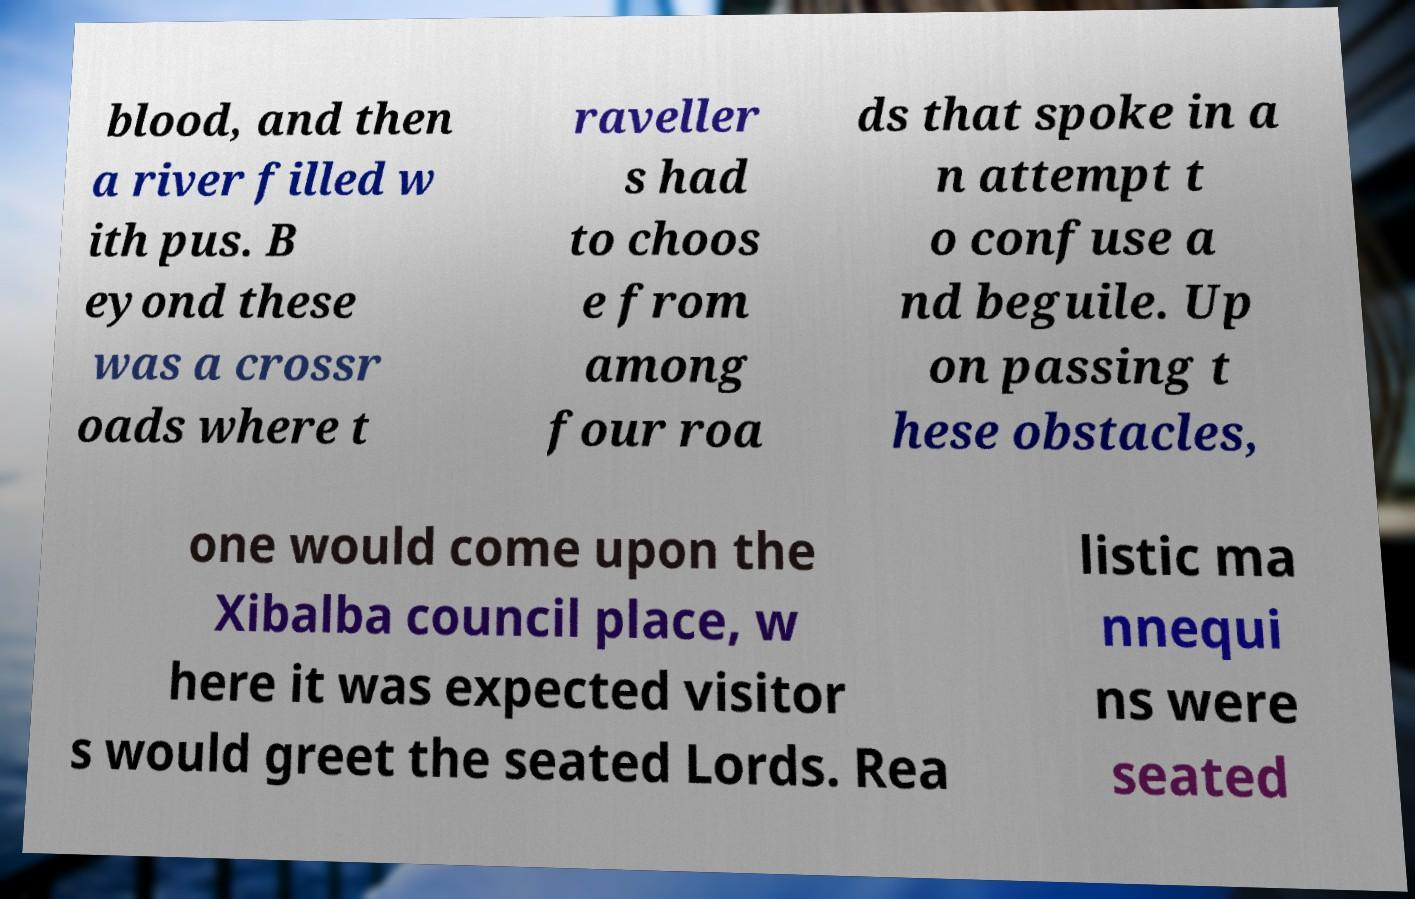Can you read and provide the text displayed in the image?This photo seems to have some interesting text. Can you extract and type it out for me? blood, and then a river filled w ith pus. B eyond these was a crossr oads where t raveller s had to choos e from among four roa ds that spoke in a n attempt t o confuse a nd beguile. Up on passing t hese obstacles, one would come upon the Xibalba council place, w here it was expected visitor s would greet the seated Lords. Rea listic ma nnequi ns were seated 